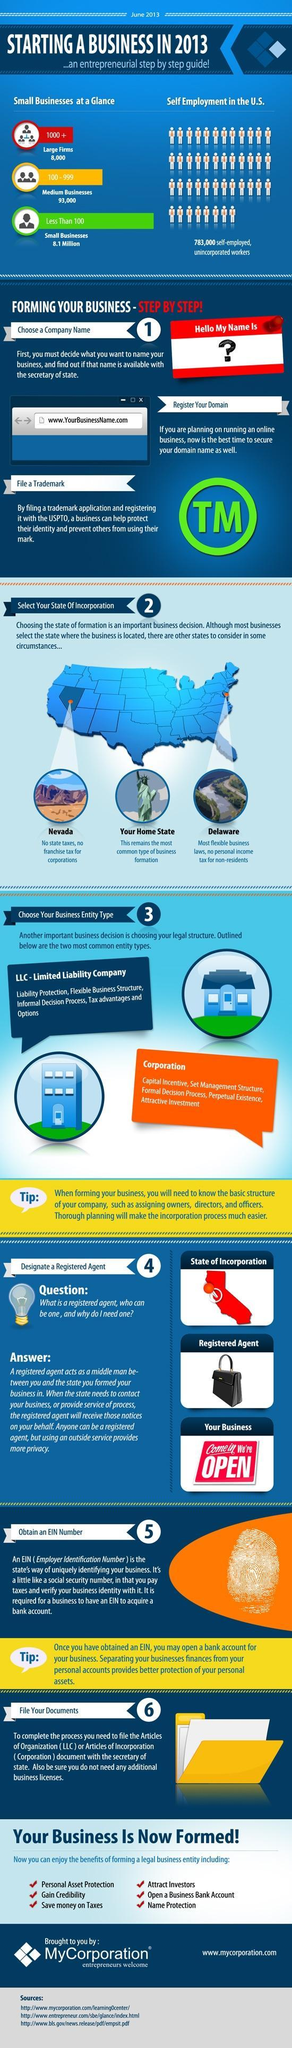What is the image shown in the fifth step of "Forming Your Business"- identity card, finger print, QR code, Bar code?
Answer the question with a short phrase. finger print What a business should do to keep their identity safe? By filing a trademark application and registering it with the USPTO Which are the two most common business entity types? LLC- Limited Liability Company, Corporation Which place is more commonly selected by most of the businesses? Your Home State What is used to differentiate every business entity? Employer Identification Number Which place needs to be chosen to start a business with zero state taxes? Nevada Which is the place suitable for start ups with zero income tax for non-residents? Delaware Who is the person to be checked with while choosing the name of the start up? secretary of state 